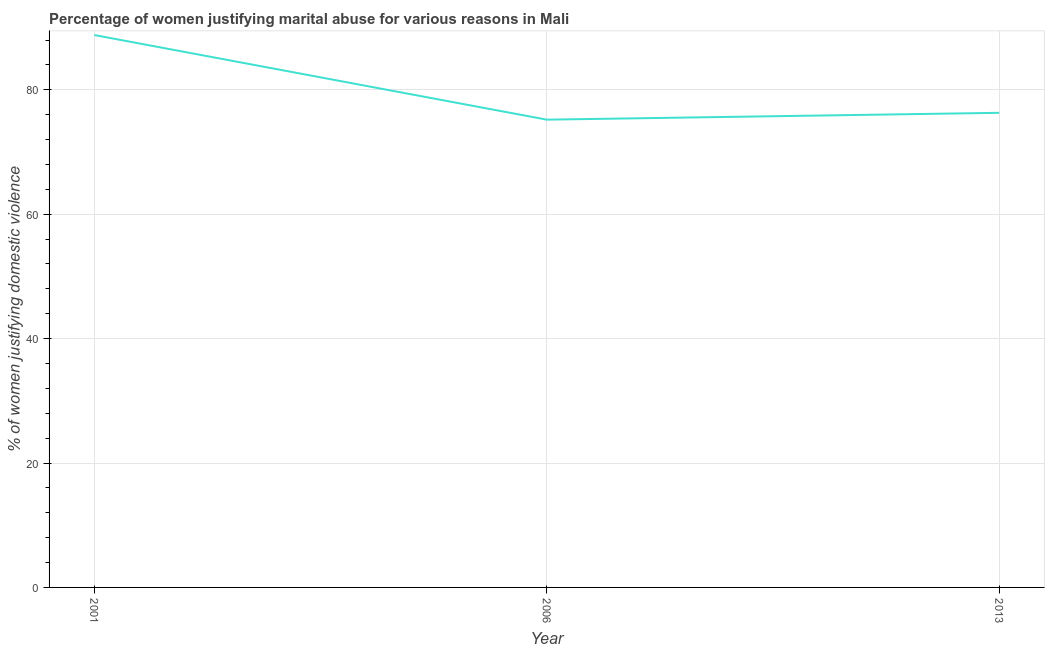What is the percentage of women justifying marital abuse in 2013?
Provide a short and direct response. 76.3. Across all years, what is the maximum percentage of women justifying marital abuse?
Ensure brevity in your answer.  88.8. Across all years, what is the minimum percentage of women justifying marital abuse?
Offer a very short reply. 75.2. What is the sum of the percentage of women justifying marital abuse?
Your answer should be very brief. 240.3. What is the difference between the percentage of women justifying marital abuse in 2001 and 2006?
Provide a short and direct response. 13.6. What is the average percentage of women justifying marital abuse per year?
Offer a terse response. 80.1. What is the median percentage of women justifying marital abuse?
Offer a terse response. 76.3. Do a majority of the years between 2013 and 2006 (inclusive) have percentage of women justifying marital abuse greater than 4 %?
Offer a terse response. No. What is the ratio of the percentage of women justifying marital abuse in 2001 to that in 2006?
Make the answer very short. 1.18. Is the difference between the percentage of women justifying marital abuse in 2006 and 2013 greater than the difference between any two years?
Your answer should be compact. No. What is the difference between the highest and the lowest percentage of women justifying marital abuse?
Keep it short and to the point. 13.6. In how many years, is the percentage of women justifying marital abuse greater than the average percentage of women justifying marital abuse taken over all years?
Make the answer very short. 1. How many lines are there?
Keep it short and to the point. 1. Does the graph contain grids?
Offer a very short reply. Yes. What is the title of the graph?
Your answer should be compact. Percentage of women justifying marital abuse for various reasons in Mali. What is the label or title of the Y-axis?
Give a very brief answer. % of women justifying domestic violence. What is the % of women justifying domestic violence of 2001?
Your response must be concise. 88.8. What is the % of women justifying domestic violence of 2006?
Your answer should be very brief. 75.2. What is the % of women justifying domestic violence of 2013?
Offer a very short reply. 76.3. What is the difference between the % of women justifying domestic violence in 2006 and 2013?
Keep it short and to the point. -1.1. What is the ratio of the % of women justifying domestic violence in 2001 to that in 2006?
Offer a very short reply. 1.18. What is the ratio of the % of women justifying domestic violence in 2001 to that in 2013?
Give a very brief answer. 1.16. What is the ratio of the % of women justifying domestic violence in 2006 to that in 2013?
Offer a very short reply. 0.99. 